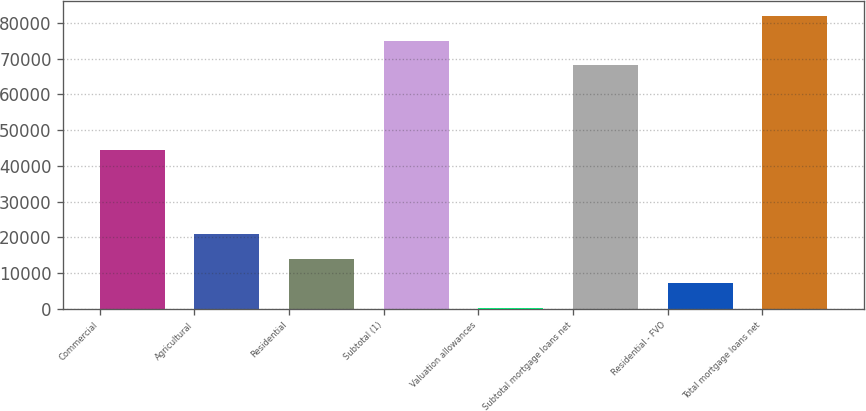Convert chart. <chart><loc_0><loc_0><loc_500><loc_500><bar_chart><fcel>Commercial<fcel>Agricultural<fcel>Residential<fcel>Subtotal (1)<fcel>Valuation allowances<fcel>Subtotal mortgage loans net<fcel>Residential - FVO<fcel>Total mortgage loans net<nl><fcel>44375<fcel>20839.1<fcel>13997.4<fcel>75052.7<fcel>314<fcel>68211<fcel>7155.7<fcel>81894.4<nl></chart> 